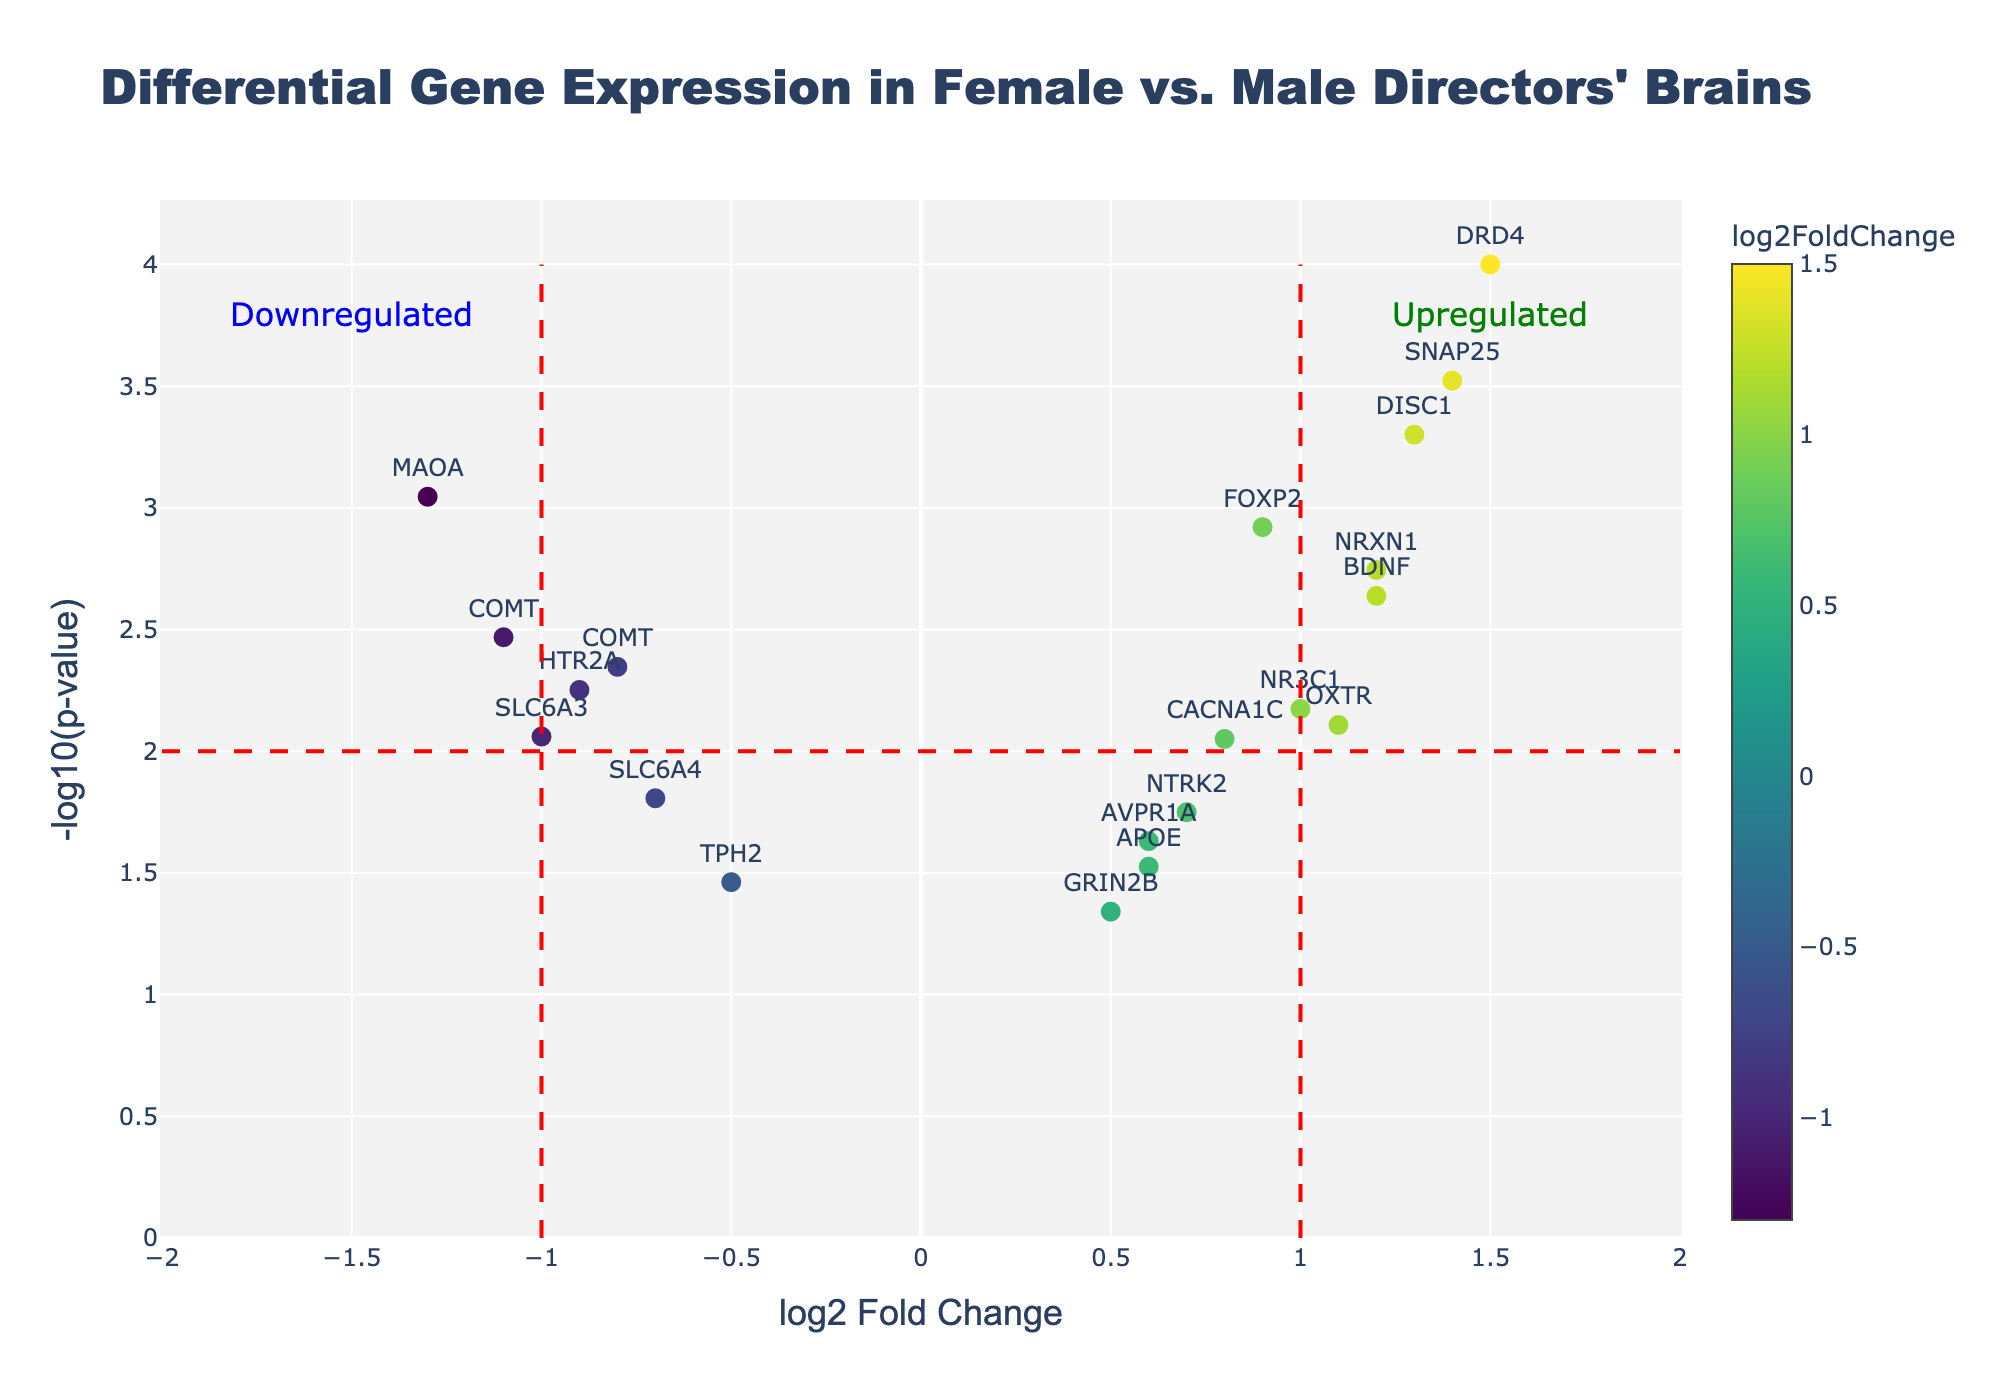How many genes are plotted in the figure? To determine this, count the total number of unique data points (genes) present on the plot. Each gene is represented by a unique marker.
Answer: 19 What is the gene with the highest -log10(p-value)? Look for the data point (gene) that is plotted at the highest y-axis value, since -log10(p-value) is represented on the y-axis.
Answer: DRD4 Which gene has the highest log2 Fold Change (log2FC)? Identify the data point (gene) that is plotted at the farthest right on the x-axis, as the log2FC is represented on the x-axis.
Answer: DRD4 How many genes have a positive log2 Fold Change and a p-value less than 0.01? Count the data points (genes) that are located on the right side of the x = 0 line (positive log2FC) and above a y-axis value of -log10(p-value) > 2 (which corresponds to p-value < 0.01).
Answer: 7 Which genes are downregulated and also have a p-value less than 0.005? Identify the data points (genes) on the left side of the x = 0 line (negative log2FC) and above the y-axis value corresponding to -log10(p-value) > 2.3 (which corresponds to p-value < 0.005).
Answer: COMT, MAOA, SLC6A3, HTR2A What are the log2 Fold Change and -log10(p-value) of the gene SNAP25? Locate the text annotation for SNAP25 in the plot and note its corresponding x (log2FC) and y (-log10(p-value)) values.
Answer: log2FC: 1.4, -log10(p-value): 3.52 Among the genes related to creativity and leadership, which one is most significantly upregulated (p-value)? Look at the genes annotated on the plot and identify those that are related to creativity and leadership. Then, determine which of these has the highest y-value.
Answer: DRD4 How many genes are upregulated with a log2 Fold Change greater than 1? Count the data points (genes) that are located to the right of the x = 1 line (log2FC > 1).
Answer: 4 Which gene has the least statistical significance but is still upregulated? Find the upregulated gene (positive log2FC) that is plotted at the lowest y-axis value, presenting the highest p-value among upregulated genes.
Answer: GRIN2B What is the overall trend seen in the -log10(p-value) distribution across upregulated and downregulated genes? Observe the distribution of data points above and below the x-axis (log2FC) line. To understand the trend within the plot, consider the overall dispersion related to the -log10(p-value).
Answer: More upregulated genes show higher statistical significance (higher -log10(p-value)) than downregulated genes 